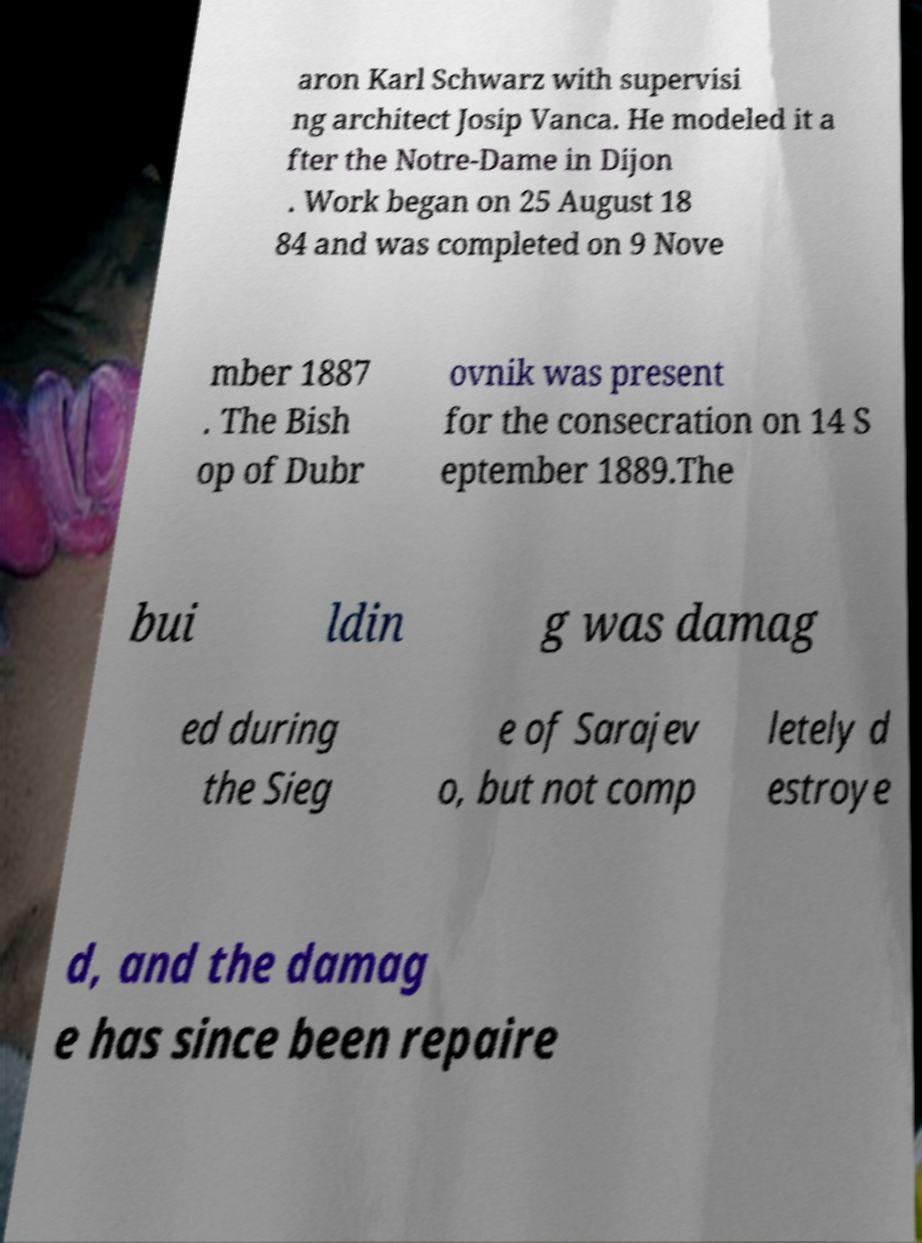Could you assist in decoding the text presented in this image and type it out clearly? aron Karl Schwarz with supervisi ng architect Josip Vanca. He modeled it a fter the Notre-Dame in Dijon . Work began on 25 August 18 84 and was completed on 9 Nove mber 1887 . The Bish op of Dubr ovnik was present for the consecration on 14 S eptember 1889.The bui ldin g was damag ed during the Sieg e of Sarajev o, but not comp letely d estroye d, and the damag e has since been repaire 